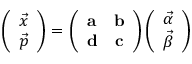<formula> <loc_0><loc_0><loc_500><loc_500>\left ( \begin{array} { c } { { \vec { x } } } \\ { { \vec { p } } } \end{array} \right ) = \left ( \begin{array} { c c } { \mathbf a } & { \mathbf b } \\ { \mathbf d } & { \mathbf c } \end{array} \right ) \left ( \begin{array} { c } { { \vec { \alpha } } } \\ { { \vec { \beta } } } \end{array} \right )</formula> 